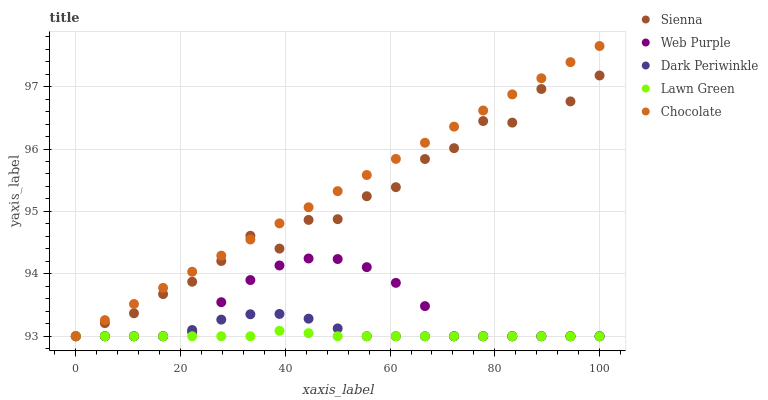Does Lawn Green have the minimum area under the curve?
Answer yes or no. Yes. Does Chocolate have the maximum area under the curve?
Answer yes or no. Yes. Does Web Purple have the minimum area under the curve?
Answer yes or no. No. Does Web Purple have the maximum area under the curve?
Answer yes or no. No. Is Chocolate the smoothest?
Answer yes or no. Yes. Is Sienna the roughest?
Answer yes or no. Yes. Is Lawn Green the smoothest?
Answer yes or no. No. Is Lawn Green the roughest?
Answer yes or no. No. Does Sienna have the lowest value?
Answer yes or no. Yes. Does Chocolate have the highest value?
Answer yes or no. Yes. Does Web Purple have the highest value?
Answer yes or no. No. Does Lawn Green intersect Chocolate?
Answer yes or no. Yes. Is Lawn Green less than Chocolate?
Answer yes or no. No. Is Lawn Green greater than Chocolate?
Answer yes or no. No. 